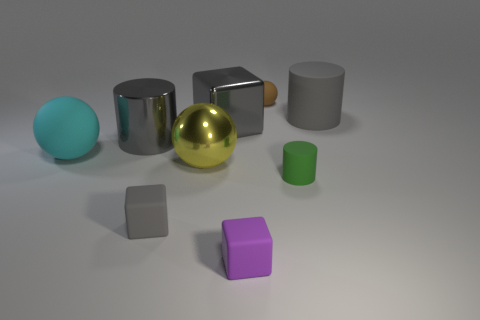What is the shape of the tiny object on the right side of the tiny ball behind the small green cylinder?
Make the answer very short. Cylinder. The metallic ball is what size?
Ensure brevity in your answer.  Large. The large cyan object has what shape?
Give a very brief answer. Sphere. Is the shape of the small purple thing the same as the small matte thing that is left of the purple rubber thing?
Provide a succinct answer. Yes. Does the big thing right of the small brown rubber sphere have the same shape as the green thing?
Your response must be concise. Yes. What number of gray blocks are both in front of the large gray block and behind the big cyan sphere?
Give a very brief answer. 0. How many other things are the same size as the purple rubber thing?
Keep it short and to the point. 3. Are there the same number of green rubber cylinders that are behind the cyan thing and small yellow objects?
Keep it short and to the point. Yes. There is a large cylinder that is left of the gray rubber cylinder; does it have the same color as the big rubber object that is behind the cyan sphere?
Your response must be concise. Yes. What material is the cylinder that is both on the right side of the tiny gray object and behind the large cyan rubber thing?
Your response must be concise. Rubber. 